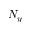<formula> <loc_0><loc_0><loc_500><loc_500>N _ { y }</formula> 